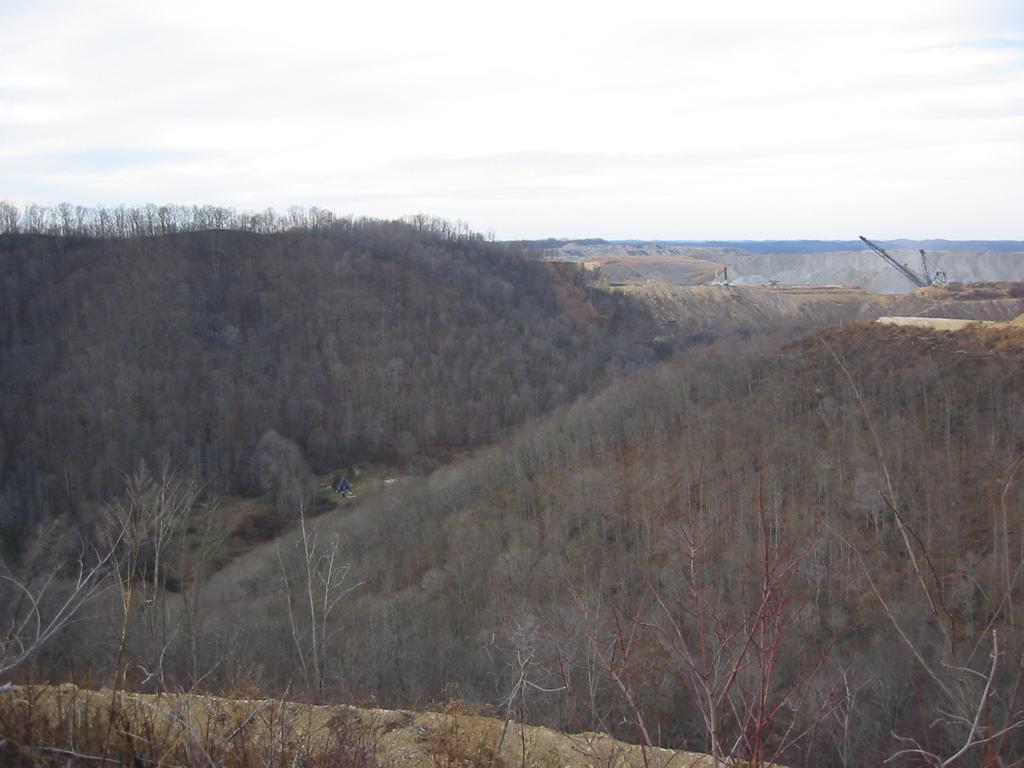In one or two sentences, can you explain what this image depicts? In this picture we can see plants, trees and crane. In the background of the image we can see the sky. 